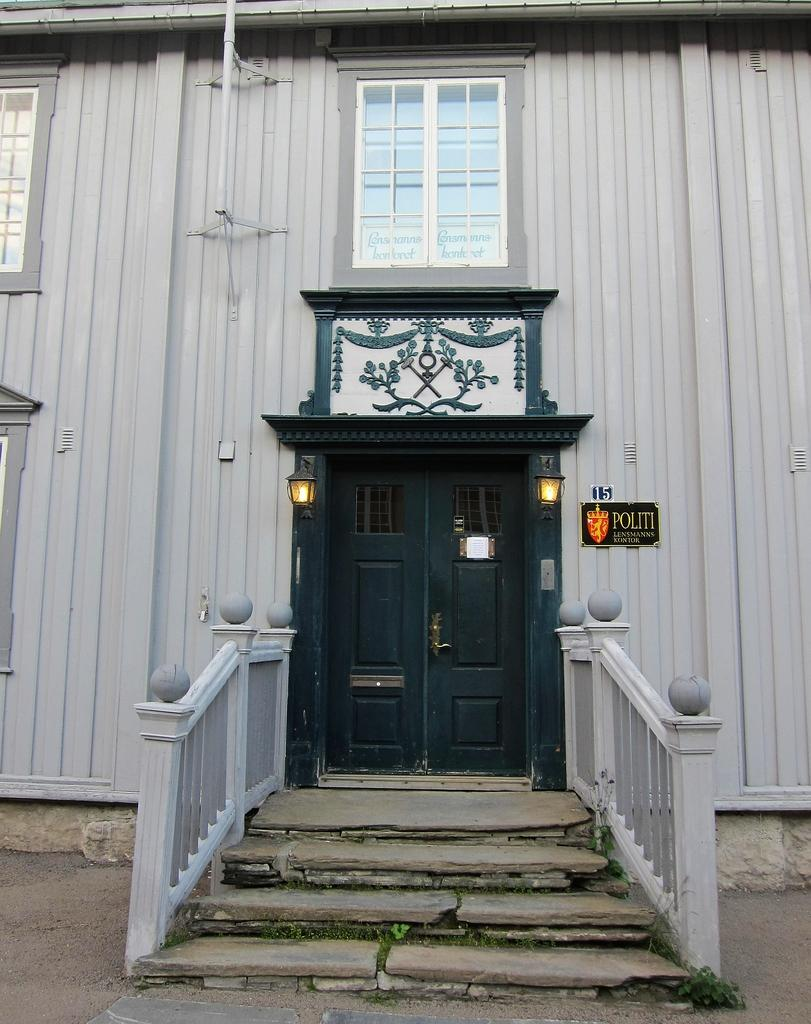What type of structure is present in the image? There is a building in the image. What features can be seen on the building? The building has a door and windows. Are there any additional elements near the door? Yes, two lights are attached on either side of the door. How can one access the building? There is a staircase before the door. What type of skate is being used to read a book on the waves in the image? There is no skate, book, or waves present in the image. 